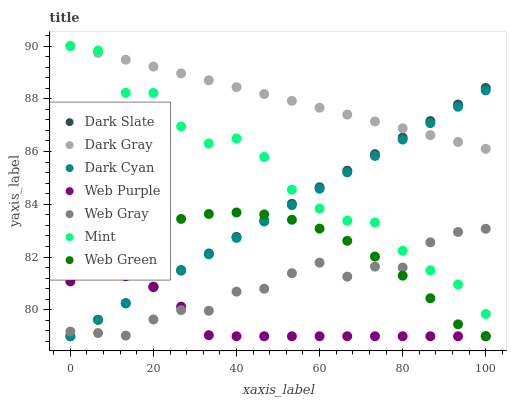Does Web Purple have the minimum area under the curve?
Answer yes or no. Yes. Does Dark Gray have the maximum area under the curve?
Answer yes or no. Yes. Does Web Green have the minimum area under the curve?
Answer yes or no. No. Does Web Green have the maximum area under the curve?
Answer yes or no. No. Is Dark Gray the smoothest?
Answer yes or no. Yes. Is Mint the roughest?
Answer yes or no. Yes. Is Web Green the smoothest?
Answer yes or no. No. Is Web Green the roughest?
Answer yes or no. No. Does Web Green have the lowest value?
Answer yes or no. Yes. Does Dark Gray have the lowest value?
Answer yes or no. No. Does Mint have the highest value?
Answer yes or no. Yes. Does Web Green have the highest value?
Answer yes or no. No. Is Web Gray less than Dark Gray?
Answer yes or no. Yes. Is Dark Gray greater than Web Purple?
Answer yes or no. Yes. Does Web Green intersect Dark Slate?
Answer yes or no. Yes. Is Web Green less than Dark Slate?
Answer yes or no. No. Is Web Green greater than Dark Slate?
Answer yes or no. No. Does Web Gray intersect Dark Gray?
Answer yes or no. No. 